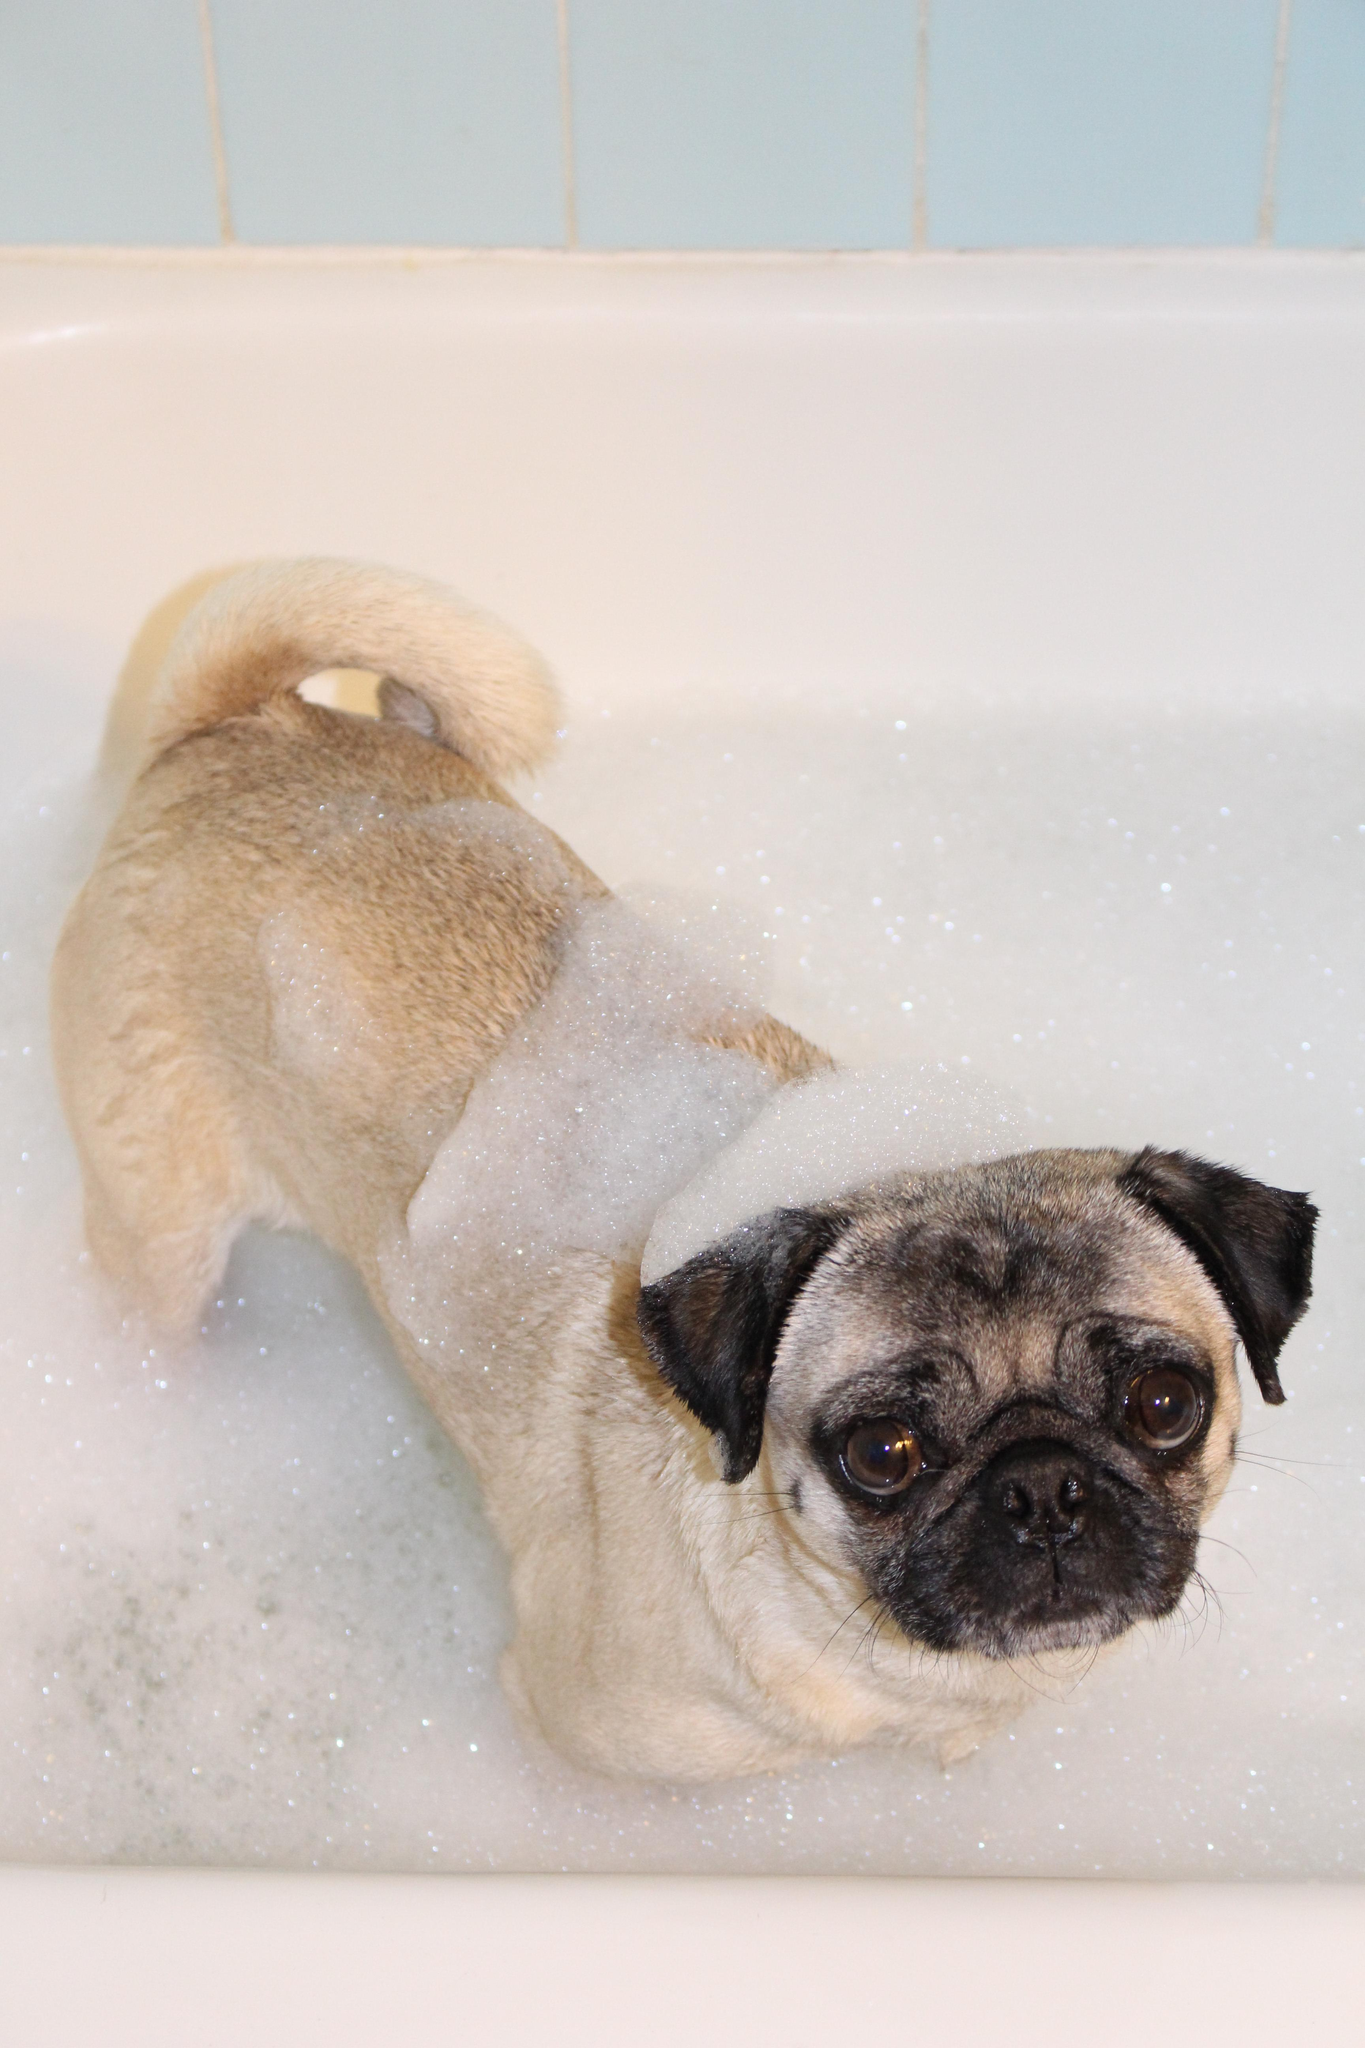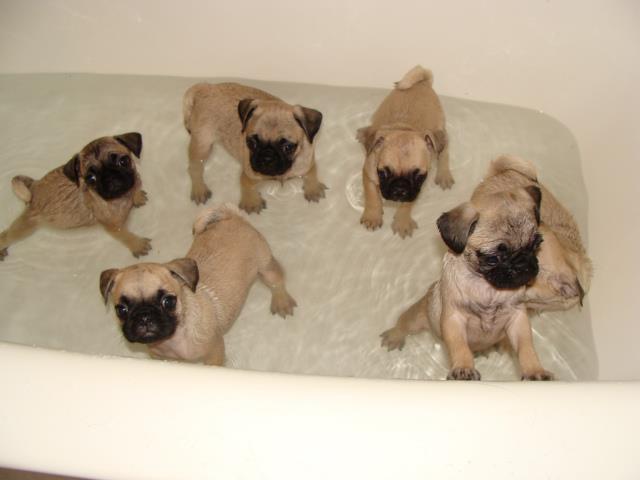The first image is the image on the left, the second image is the image on the right. Considering the images on both sides, is "there are 4 dogs bathing in the image pair" valid? Answer yes or no. No. The first image is the image on the left, the second image is the image on the right. Given the left and right images, does the statement "One dog has soap on his back." hold true? Answer yes or no. Yes. 